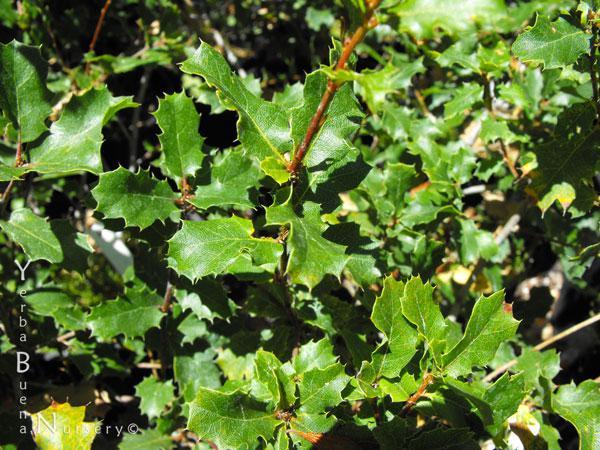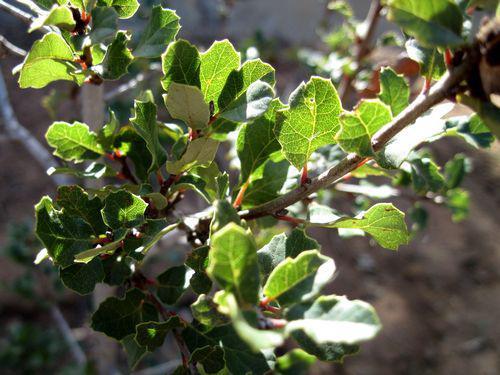The first image is the image on the left, the second image is the image on the right. For the images shown, is this caption "One of the images is an acorn close up and the other only shows branches and leaves." true? Answer yes or no. No. The first image is the image on the left, the second image is the image on the right. Analyze the images presented: Is the assertion "The left image shows two green acorns in the foreground which lack any brown patches on their skins, and the right image shows foliage without individually distinguishable acorns." valid? Answer yes or no. No. 